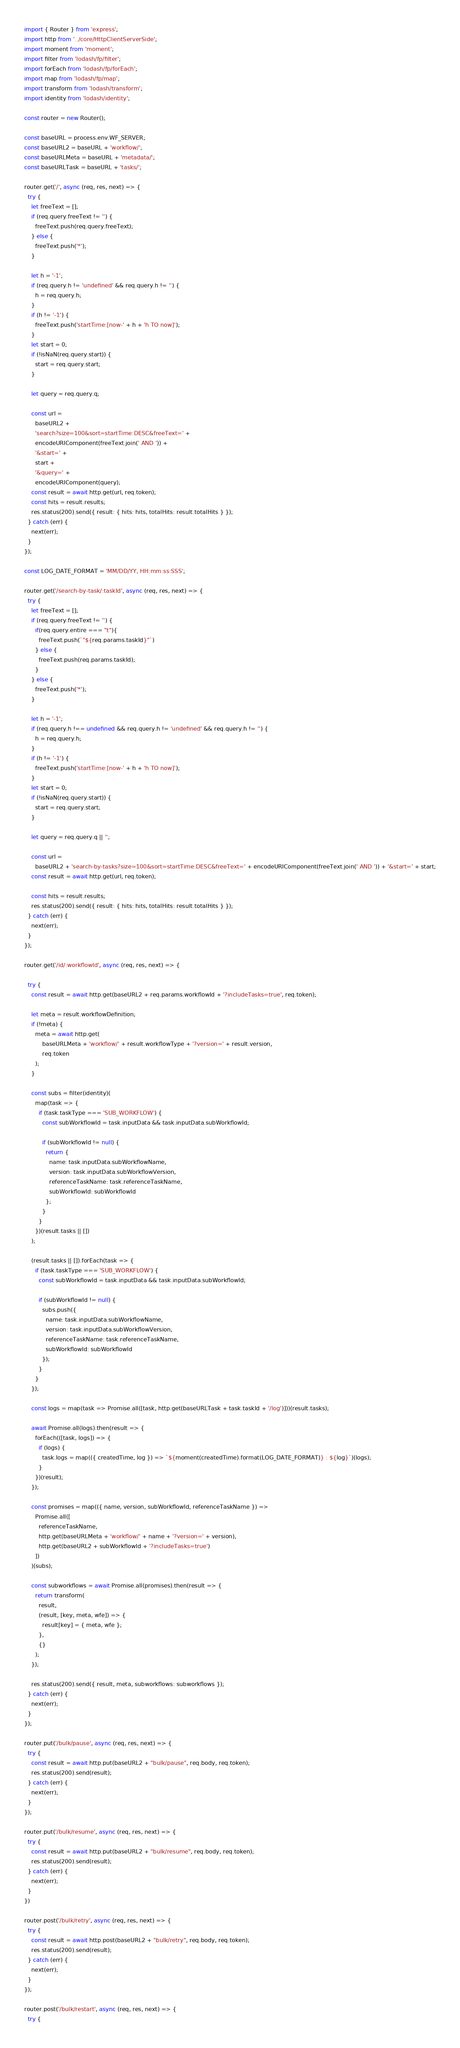<code> <loc_0><loc_0><loc_500><loc_500><_JavaScript_>import { Router } from 'express';
import http from '../core/HttpClientServerSide';
import moment from 'moment';
import filter from 'lodash/fp/filter';
import forEach from 'lodash/fp/forEach';
import map from 'lodash/fp/map';
import transform from 'lodash/transform';
import identity from 'lodash/identity';

const router = new Router();

const baseURL = process.env.WF_SERVER;
const baseURL2 = baseURL + 'workflow/';
const baseURLMeta = baseURL + 'metadata/';
const baseURLTask = baseURL + 'tasks/';

router.get('/', async (req, res, next) => {
  try {
    let freeText = [];
    if (req.query.freeText != '') {
      freeText.push(req.query.freeText);
    } else {
      freeText.push('*');
    }

    let h = '-1';
    if (req.query.h != 'undefined' && req.query.h != '') {
      h = req.query.h;
    }
    if (h != '-1') {
      freeText.push('startTime:[now-' + h + 'h TO now]');
    }
    let start = 0;
    if (!isNaN(req.query.start)) {
      start = req.query.start;
    }

    let query = req.query.q;

    const url =
      baseURL2 +
      'search?size=100&sort=startTime:DESC&freeText=' +
      encodeURIComponent(freeText.join(' AND ')) +
      '&start=' +
      start +
      '&query=' +
      encodeURIComponent(query);
    const result = await http.get(url, req.token);
    const hits = result.results;
    res.status(200).send({ result: { hits: hits, totalHits: result.totalHits } });
  } catch (err) {
    next(err);
  }
});

const LOG_DATE_FORMAT = 'MM/DD/YY, HH:mm:ss:SSS';

router.get('/search-by-task/:taskId', async (req, res, next) => {
  try {
    let freeText = [];
    if (req.query.freeText != '') {
      if(req.query.entire === "t"){
        freeText.push(`"${req.params.taskId}"`)
      } else {
        freeText.push(req.params.taskId);
      }
    } else {
      freeText.push('*');
    }

    let h = '-1';
    if (req.query.h !== undefined && req.query.h != 'undefined' && req.query.h != '') {
      h = req.query.h;
    }
    if (h != '-1') {
      freeText.push('startTime:[now-' + h + 'h TO now]');
    }
    let start = 0;
    if (!isNaN(req.query.start)) {
      start = req.query.start;
    }

    let query = req.query.q || '';

    const url =
      baseURL2 + 'search-by-tasks?size=100&sort=startTime:DESC&freeText=' + encodeURIComponent(freeText.join(' AND ')) + '&start=' + start;
    const result = await http.get(url, req.token);

    const hits = result.results;
    res.status(200).send({ result: { hits: hits, totalHits: result.totalHits } });
  } catch (err) {
    next(err);
  }
});

router.get('/id/:workflowId', async (req, res, next) => {

  try {
    const result = await http.get(baseURL2 + req.params.workflowId + '?includeTasks=true', req.token);

    let meta = result.workflowDefinition;
    if (!meta) {
      meta = await http.get(
          baseURLMeta + 'workflow/' + result.workflowType + '?version=' + result.version,
          req.token
      );
    }

    const subs = filter(identity)(
      map(task => {
        if (task.taskType === 'SUB_WORKFLOW') {
          const subWorkflowId = task.inputData && task.inputData.subWorkflowId;

          if (subWorkflowId != null) {
            return {
              name: task.inputData.subWorkflowName,
              version: task.inputData.subWorkflowVersion,
              referenceTaskName: task.referenceTaskName,
              subWorkflowId: subWorkflowId
            };
          }
        }
      })(result.tasks || [])
    );

    (result.tasks || []).forEach(task => {
      if (task.taskType === 'SUB_WORKFLOW') {
        const subWorkflowId = task.inputData && task.inputData.subWorkflowId;

        if (subWorkflowId != null) {
          subs.push({
            name: task.inputData.subWorkflowName,
            version: task.inputData.subWorkflowVersion,
            referenceTaskName: task.referenceTaskName,
            subWorkflowId: subWorkflowId
          });
        }
      }
    });

    const logs = map(task => Promise.all([task, http.get(baseURLTask + task.taskId + '/log')]))(result.tasks);

    await Promise.all(logs).then(result => {
      forEach(([task, logs]) => {
        if (logs) {
          task.logs = map(({ createdTime, log }) => `${moment(createdTime).format(LOG_DATE_FORMAT)} : ${log}`)(logs);
        }
      })(result);
    });

    const promises = map(({ name, version, subWorkflowId, referenceTaskName }) =>
      Promise.all([
        referenceTaskName,
        http.get(baseURLMeta + 'workflow/' + name + '?version=' + version),
        http.get(baseURL2 + subWorkflowId + '?includeTasks=true')
      ])
    )(subs);

    const subworkflows = await Promise.all(promises).then(result => {
      return transform(
        result,
        (result, [key, meta, wfe]) => {
          result[key] = { meta, wfe };
        },
        {}
      );
    });

    res.status(200).send({ result, meta, subworkflows: subworkflows });
  } catch (err) {
    next(err);
  }
});

router.put('/bulk/pause', async (req, res, next) => {
  try {
    const result = await http.put(baseURL2 + "bulk/pause", req.body, req.token);
    res.status(200).send(result);
  } catch (err) {
    next(err);
  }
});

router.put('/bulk/resume', async (req, res, next) => {
  try {
    const result = await http.put(baseURL2 + "bulk/resume", req.body, req.token);
    res.status(200).send(result);
  } catch (err) {
    next(err);
  }
})

router.post('/bulk/retry', async (req, res, next) => {
  try {
    const result = await http.post(baseURL2 + "bulk/retry", req.body, req.token);
    res.status(200).send(result);
  } catch (err) {
    next(err);
  }
});

router.post('/bulk/restart', async (req, res, next) => {
  try {</code> 